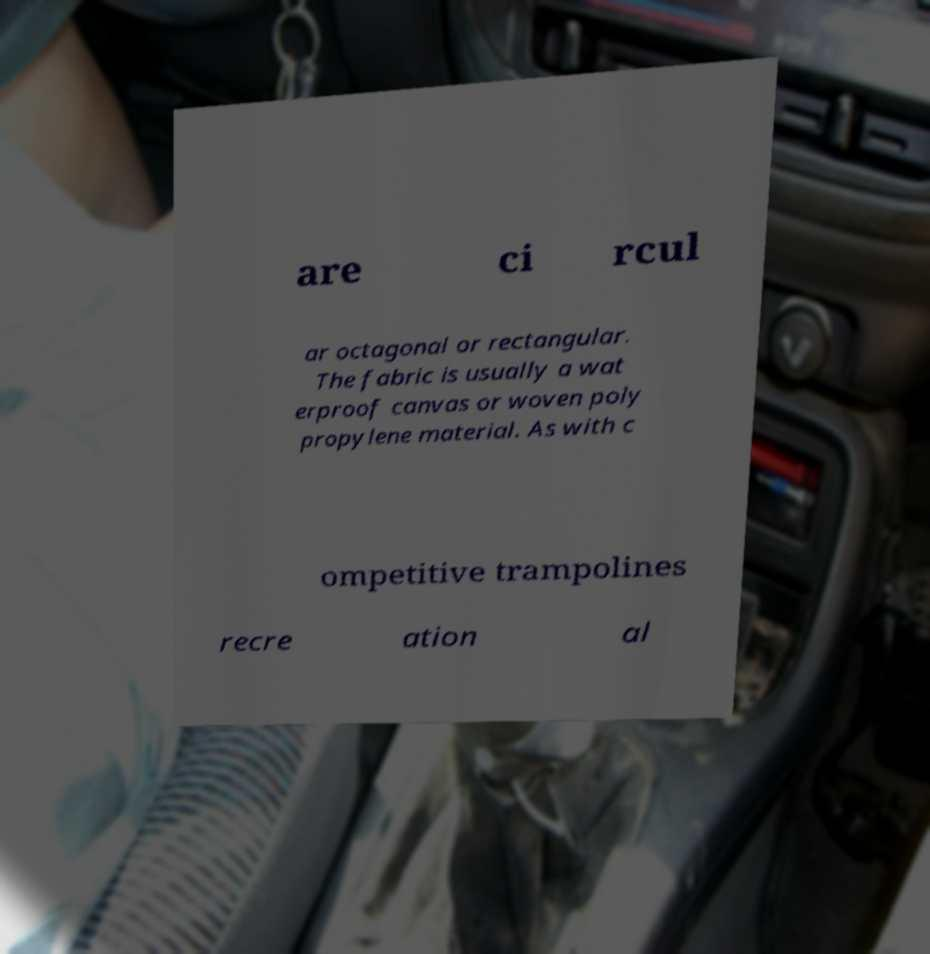Could you assist in decoding the text presented in this image and type it out clearly? are ci rcul ar octagonal or rectangular. The fabric is usually a wat erproof canvas or woven poly propylene material. As with c ompetitive trampolines recre ation al 